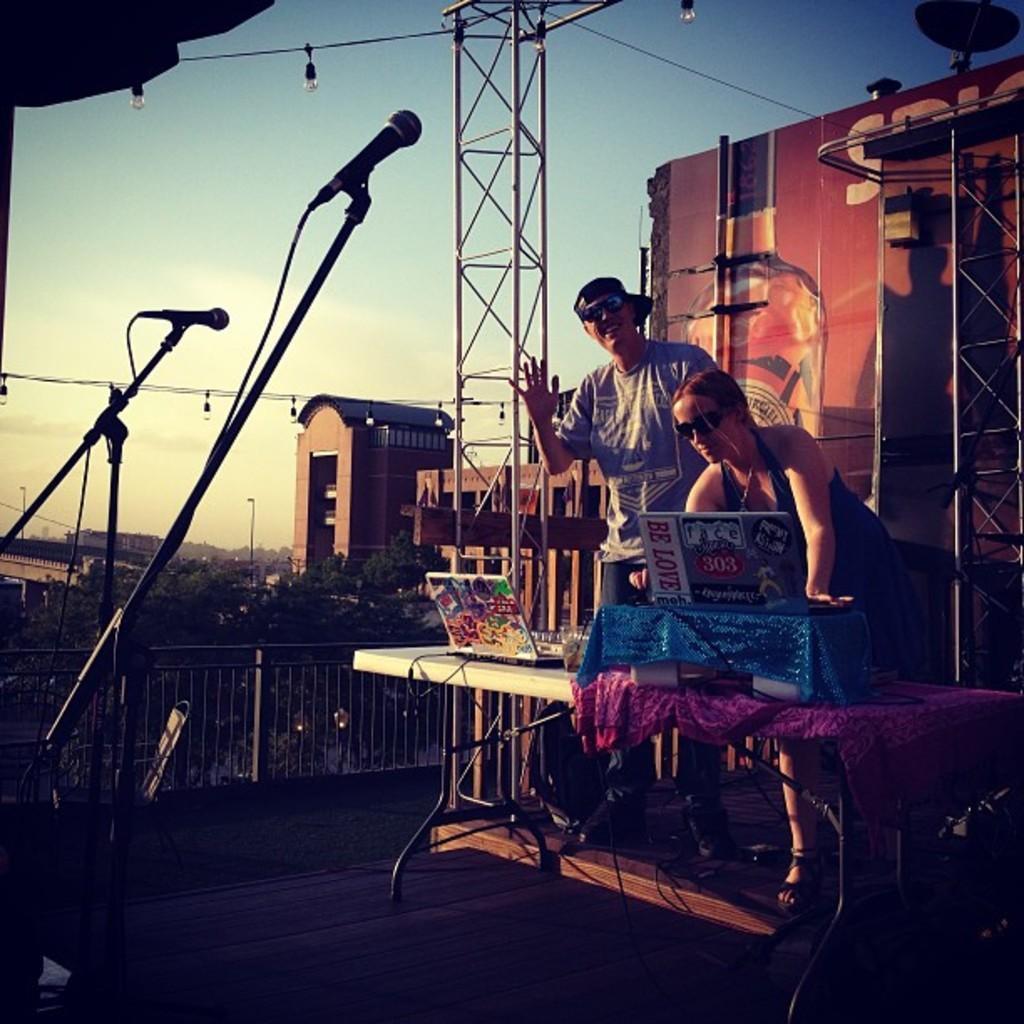How would you summarize this image in a sentence or two? There are two persons standing. This is a table with two laptops and I can see another object covered with blue cloth. Under the table I can see a bag and some cables. These are the mics attached with a mike stand. At background I can see buildings and trees. These are the lights hanging. This looks like a poster. 